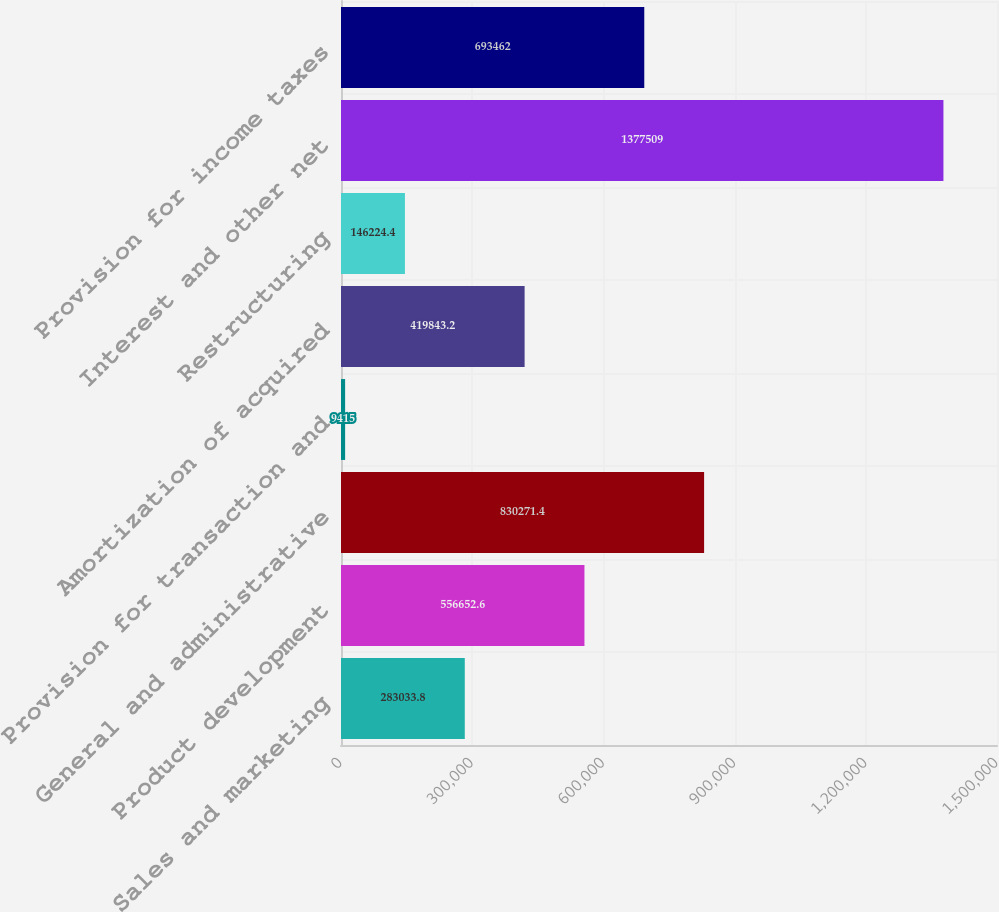<chart> <loc_0><loc_0><loc_500><loc_500><bar_chart><fcel>Sales and marketing<fcel>Product development<fcel>General and administrative<fcel>Provision for transaction and<fcel>Amortization of acquired<fcel>Restructuring<fcel>Interest and other net<fcel>Provision for income taxes<nl><fcel>283034<fcel>556653<fcel>830271<fcel>9415<fcel>419843<fcel>146224<fcel>1.37751e+06<fcel>693462<nl></chart> 